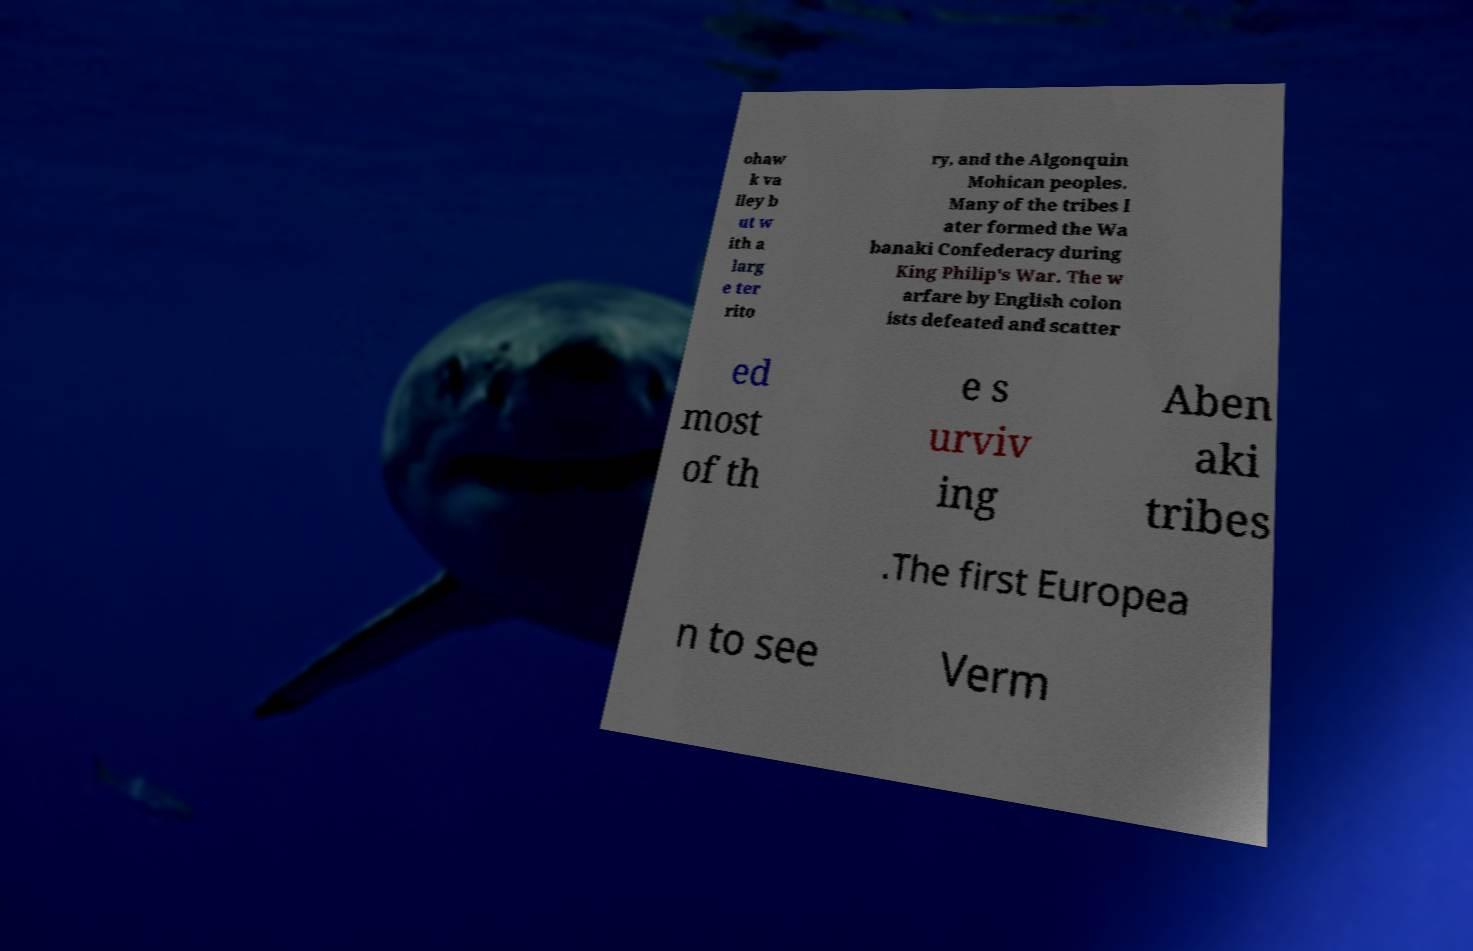Can you accurately transcribe the text from the provided image for me? ohaw k va lley b ut w ith a larg e ter rito ry, and the Algonquin Mohican peoples. Many of the tribes l ater formed the Wa banaki Confederacy during King Philip's War. The w arfare by English colon ists defeated and scatter ed most of th e s urviv ing Aben aki tribes .The first Europea n to see Verm 